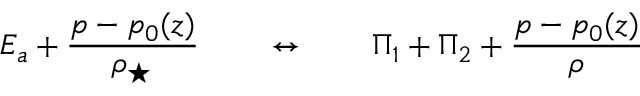<formula> <loc_0><loc_0><loc_500><loc_500>E _ { a } + \frac { p - p _ { 0 } ( z ) } { \rho _ { ^ { * } } } \quad \leftrightarrow \quad \Pi _ { 1 } + \Pi _ { 2 } + \frac { p - p _ { 0 } ( z ) } { \rho }</formula> 